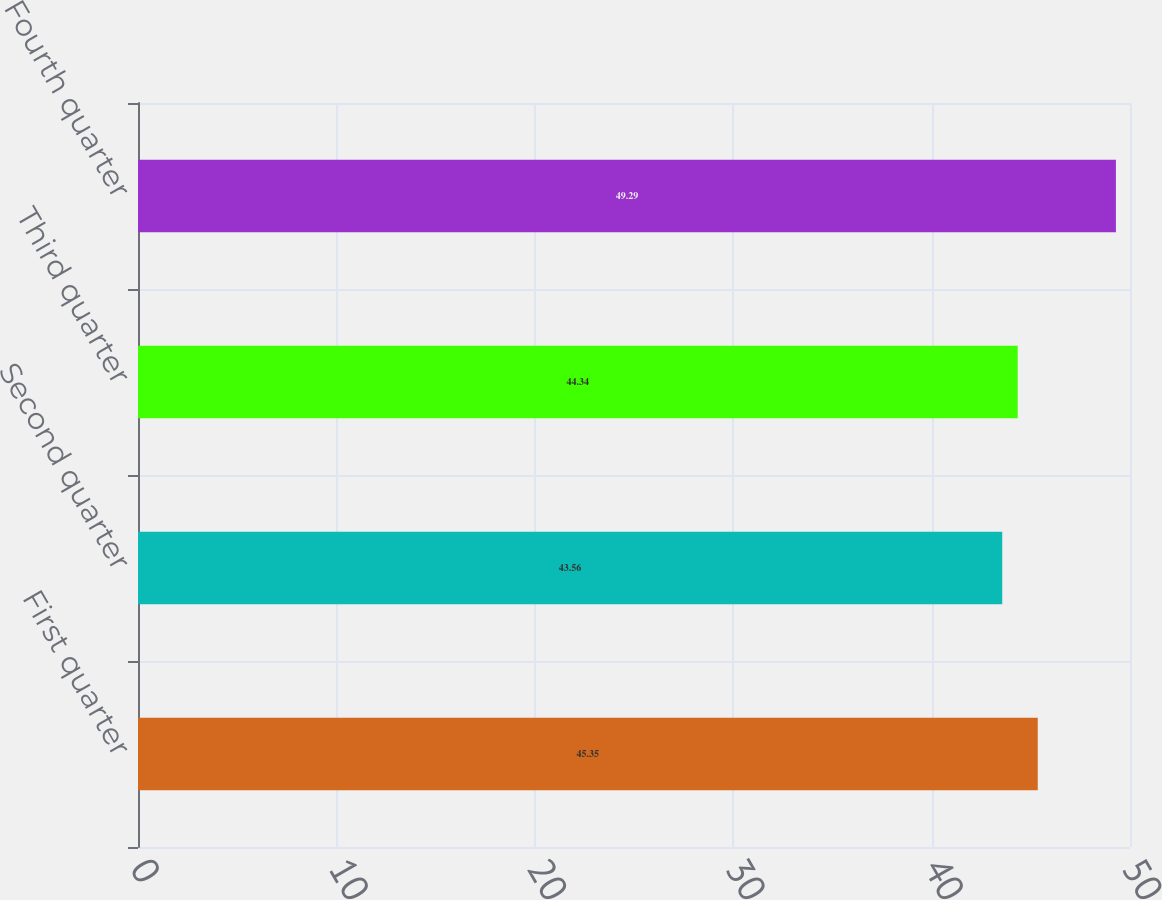Convert chart to OTSL. <chart><loc_0><loc_0><loc_500><loc_500><bar_chart><fcel>First quarter<fcel>Second quarter<fcel>Third quarter<fcel>Fourth quarter<nl><fcel>45.35<fcel>43.56<fcel>44.34<fcel>49.29<nl></chart> 